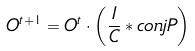Convert formula to latex. <formula><loc_0><loc_0><loc_500><loc_500>O ^ { t + 1 } = O ^ { t } \cdot \left ( \frac { I } { C } \ast c o n j P \right ) \\</formula> 